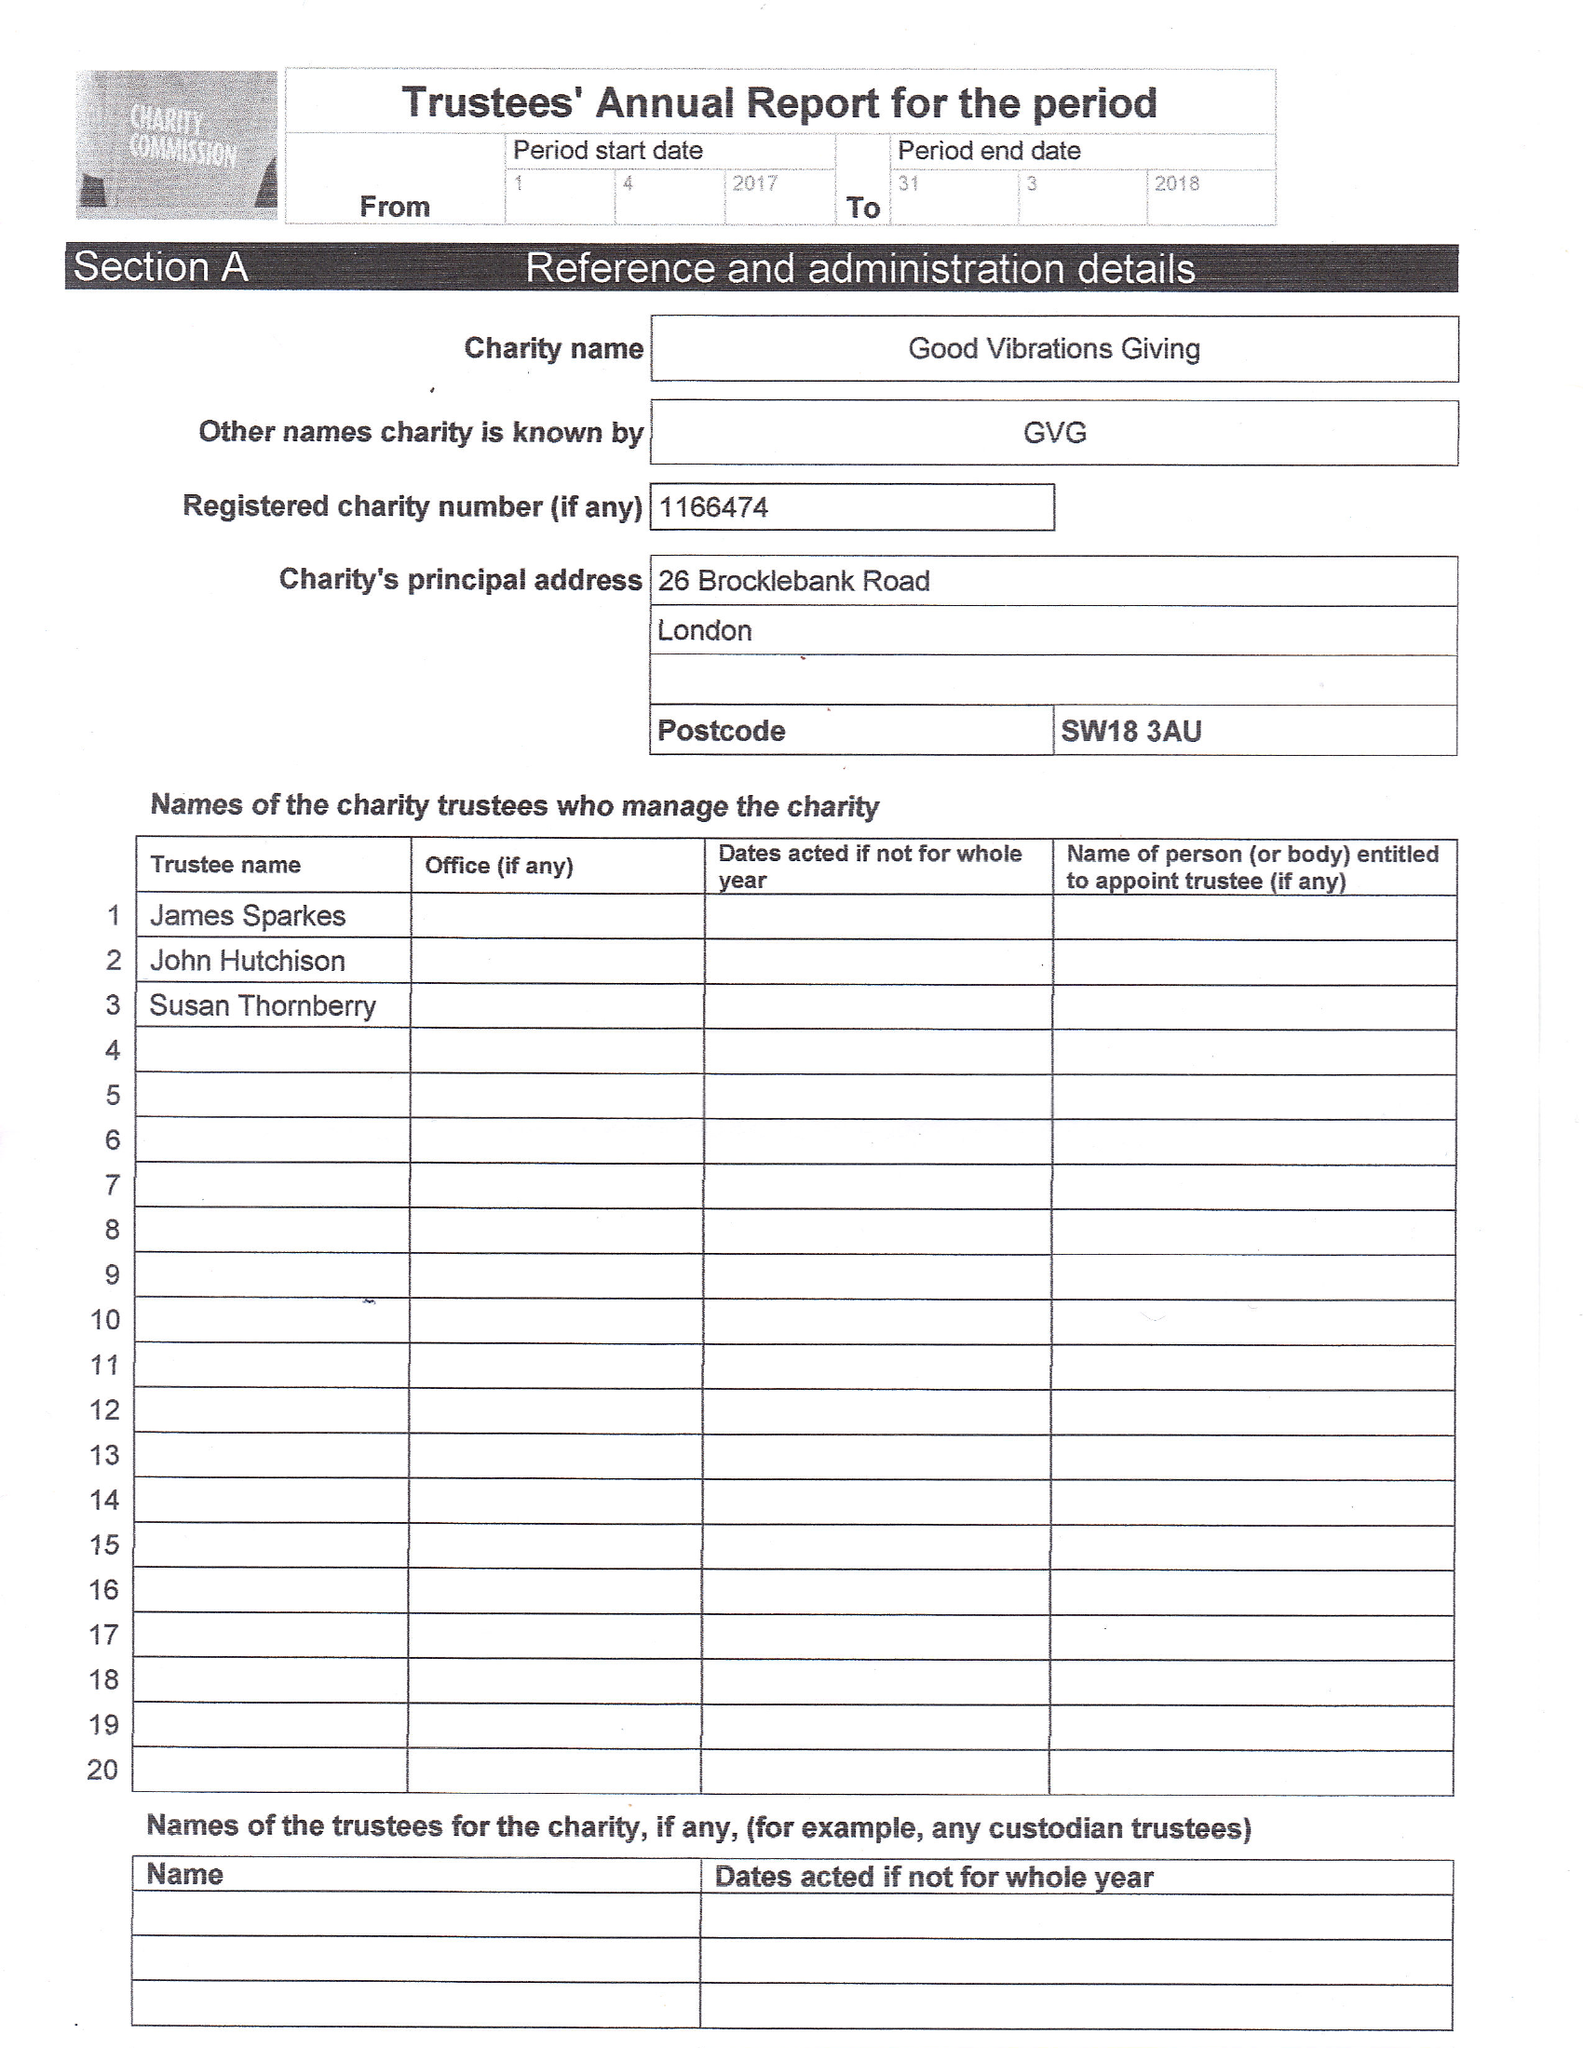What is the value for the address__postcode?
Answer the question using a single word or phrase. SW18 3AU 